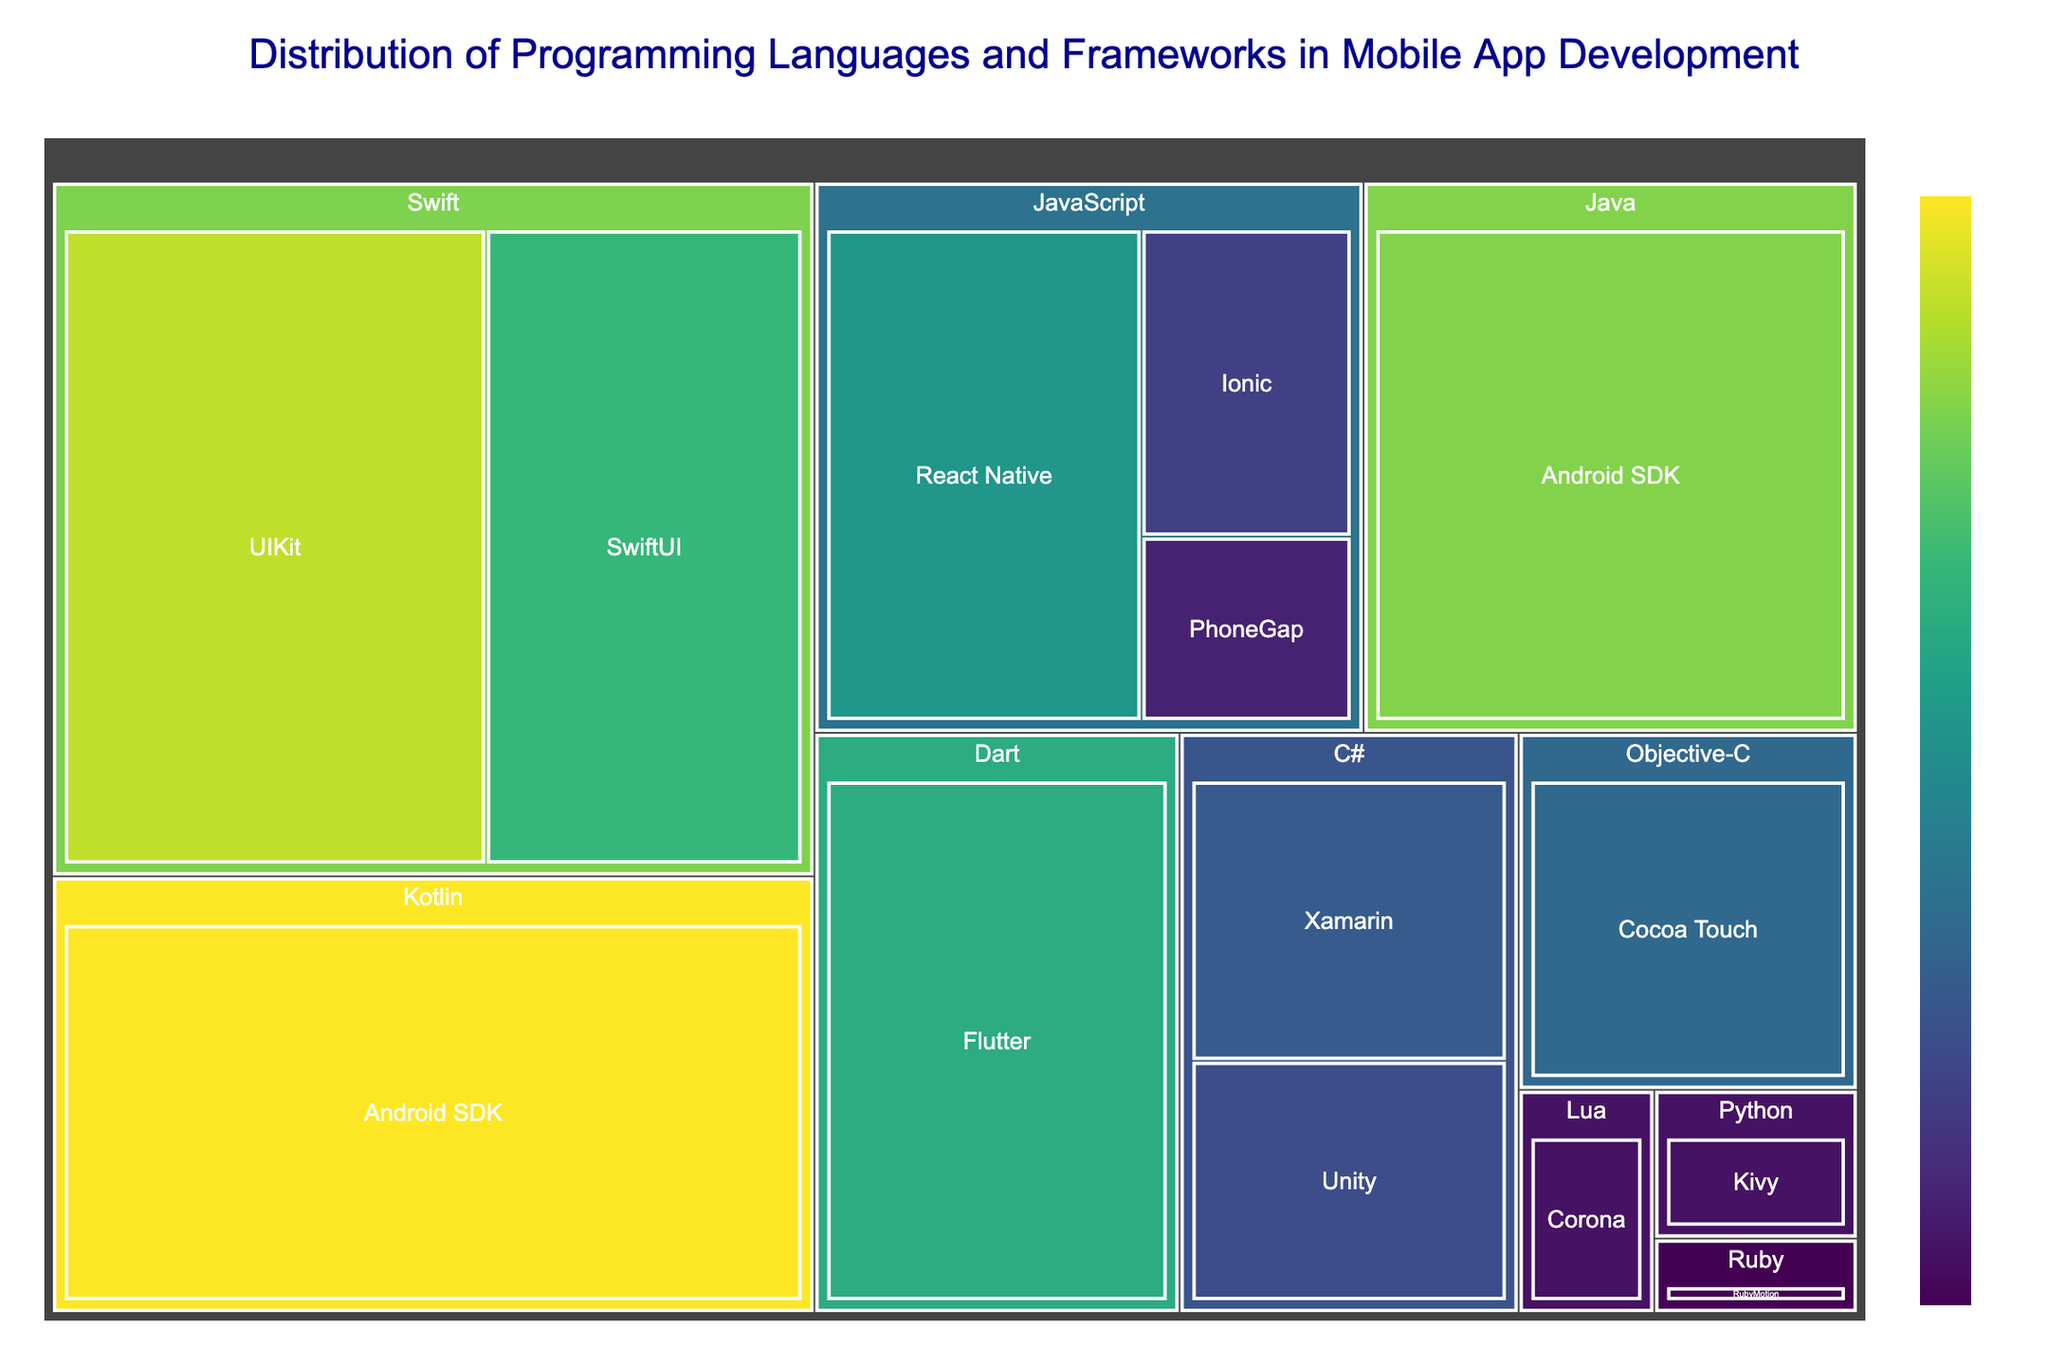What is the title of the treemap? The title is displayed at the top of the treemap indicating the overall information being presented.
Answer: "Distribution of Programming Languages and Frameworks in Mobile App Development" Which programming language has the highest usage in mobile app development? To determine the language with the highest usage, look for the largest section on the treemap and refer to the label.
Answer: Kotlin How much is the combined usage of Swift frameworks? Add the usage values for Swift's frameworks (UIKit and SwiftUI). Swift (20 for UIKit, 15 for SwiftUI) is 20 + 15.
Answer: 35 Which framework under JavaScript has the lowest usage? Among the frameworks listed under JavaScript, find the one with the smallest section. JavaScript (PhoneGap has 3, the lowest usage).
Answer: PhoneGap How does the usage of SwiftUI compare to that of Flutter? Compare the sizes directly from the figure or refer to the numerical values given for SwiftUI (15) and Flutter (14).
Answer: SwiftUI has slightly higher usage than Flutter Which programming language has the least number of frameworks depicted? Count the number of frameworks listed under each programming language. Languages with only one framework are Python (Kivy), Ruby (RubyMotion), and Lua (Corona).
Answer: Python/Ruby/Lua What is the total usage of all JavaScript frameworks combined? Sum up the usage values for all JavaScript frameworks (React Native, Ionic, PhoneGap). JavaScript (12 + 5 + 3) is 12 + 5 + 3.
Answer: 20 Among C# frameworks, which one has higher usage? Compare the usage values of Xamarin and Unity. Unity's usage (6) is less than Xamarin's usage (7).
Answer: Xamarin Which programming language associated with 'Android SDK' has more usage? Compare the usage values for Java and Kotlin under Android SDK. Kotlin (22) is higher than Java (18).
Answer: Kotlin What’s the total usage of frameworks under Swift and Java combined? Sum the usage values for all frameworks under both Swift and Java (Swift: 20+15, Java: 18). Swift (35) + Java (18) is 35 + 18.
Answer: 53 